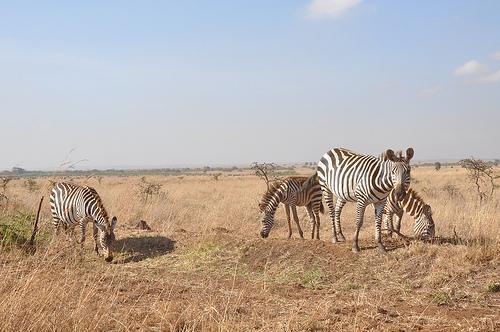How many zebras are in the photo?
Give a very brief answer. 4. How many zebras are standing?
Give a very brief answer. 4. 